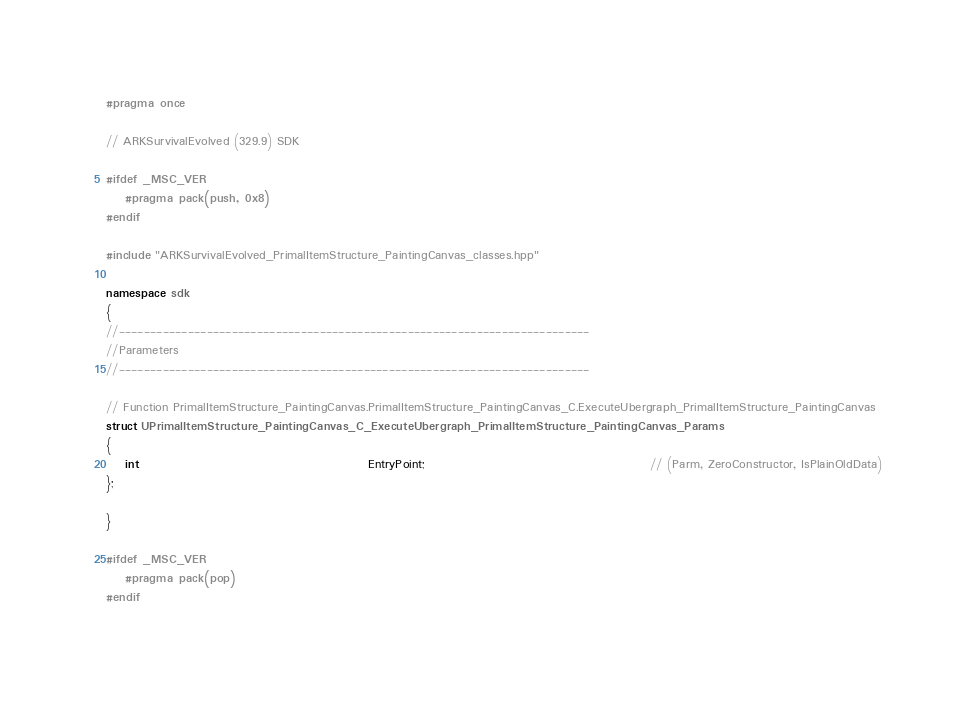Convert code to text. <code><loc_0><loc_0><loc_500><loc_500><_C++_>#pragma once

// ARKSurvivalEvolved (329.9) SDK

#ifdef _MSC_VER
	#pragma pack(push, 0x8)
#endif

#include "ARKSurvivalEvolved_PrimalItemStructure_PaintingCanvas_classes.hpp"

namespace sdk
{
//---------------------------------------------------------------------------
//Parameters
//---------------------------------------------------------------------------

// Function PrimalItemStructure_PaintingCanvas.PrimalItemStructure_PaintingCanvas_C.ExecuteUbergraph_PrimalItemStructure_PaintingCanvas
struct UPrimalItemStructure_PaintingCanvas_C_ExecuteUbergraph_PrimalItemStructure_PaintingCanvas_Params
{
	int                                                EntryPoint;                                               // (Parm, ZeroConstructor, IsPlainOldData)
};

}

#ifdef _MSC_VER
	#pragma pack(pop)
#endif
</code> 